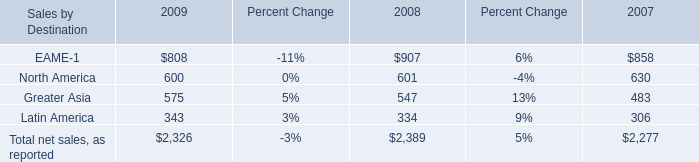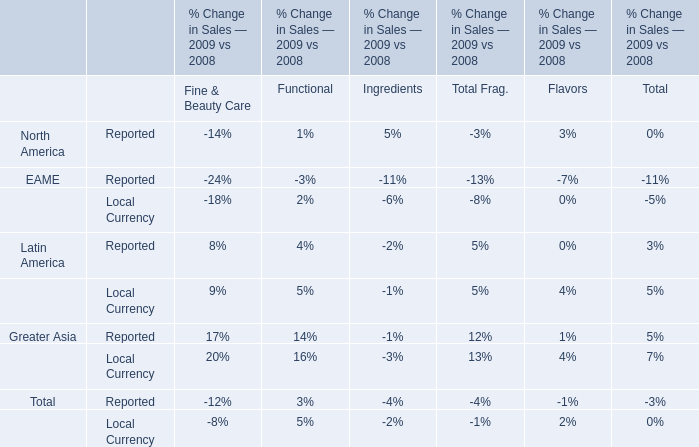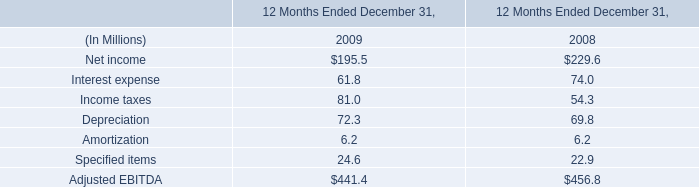In As the chart 0, what is the growth rate of Total net sales, as reported between 2008 and 2009? 
Computations: ((2326 - 2389) / 2389)
Answer: -0.02637. 